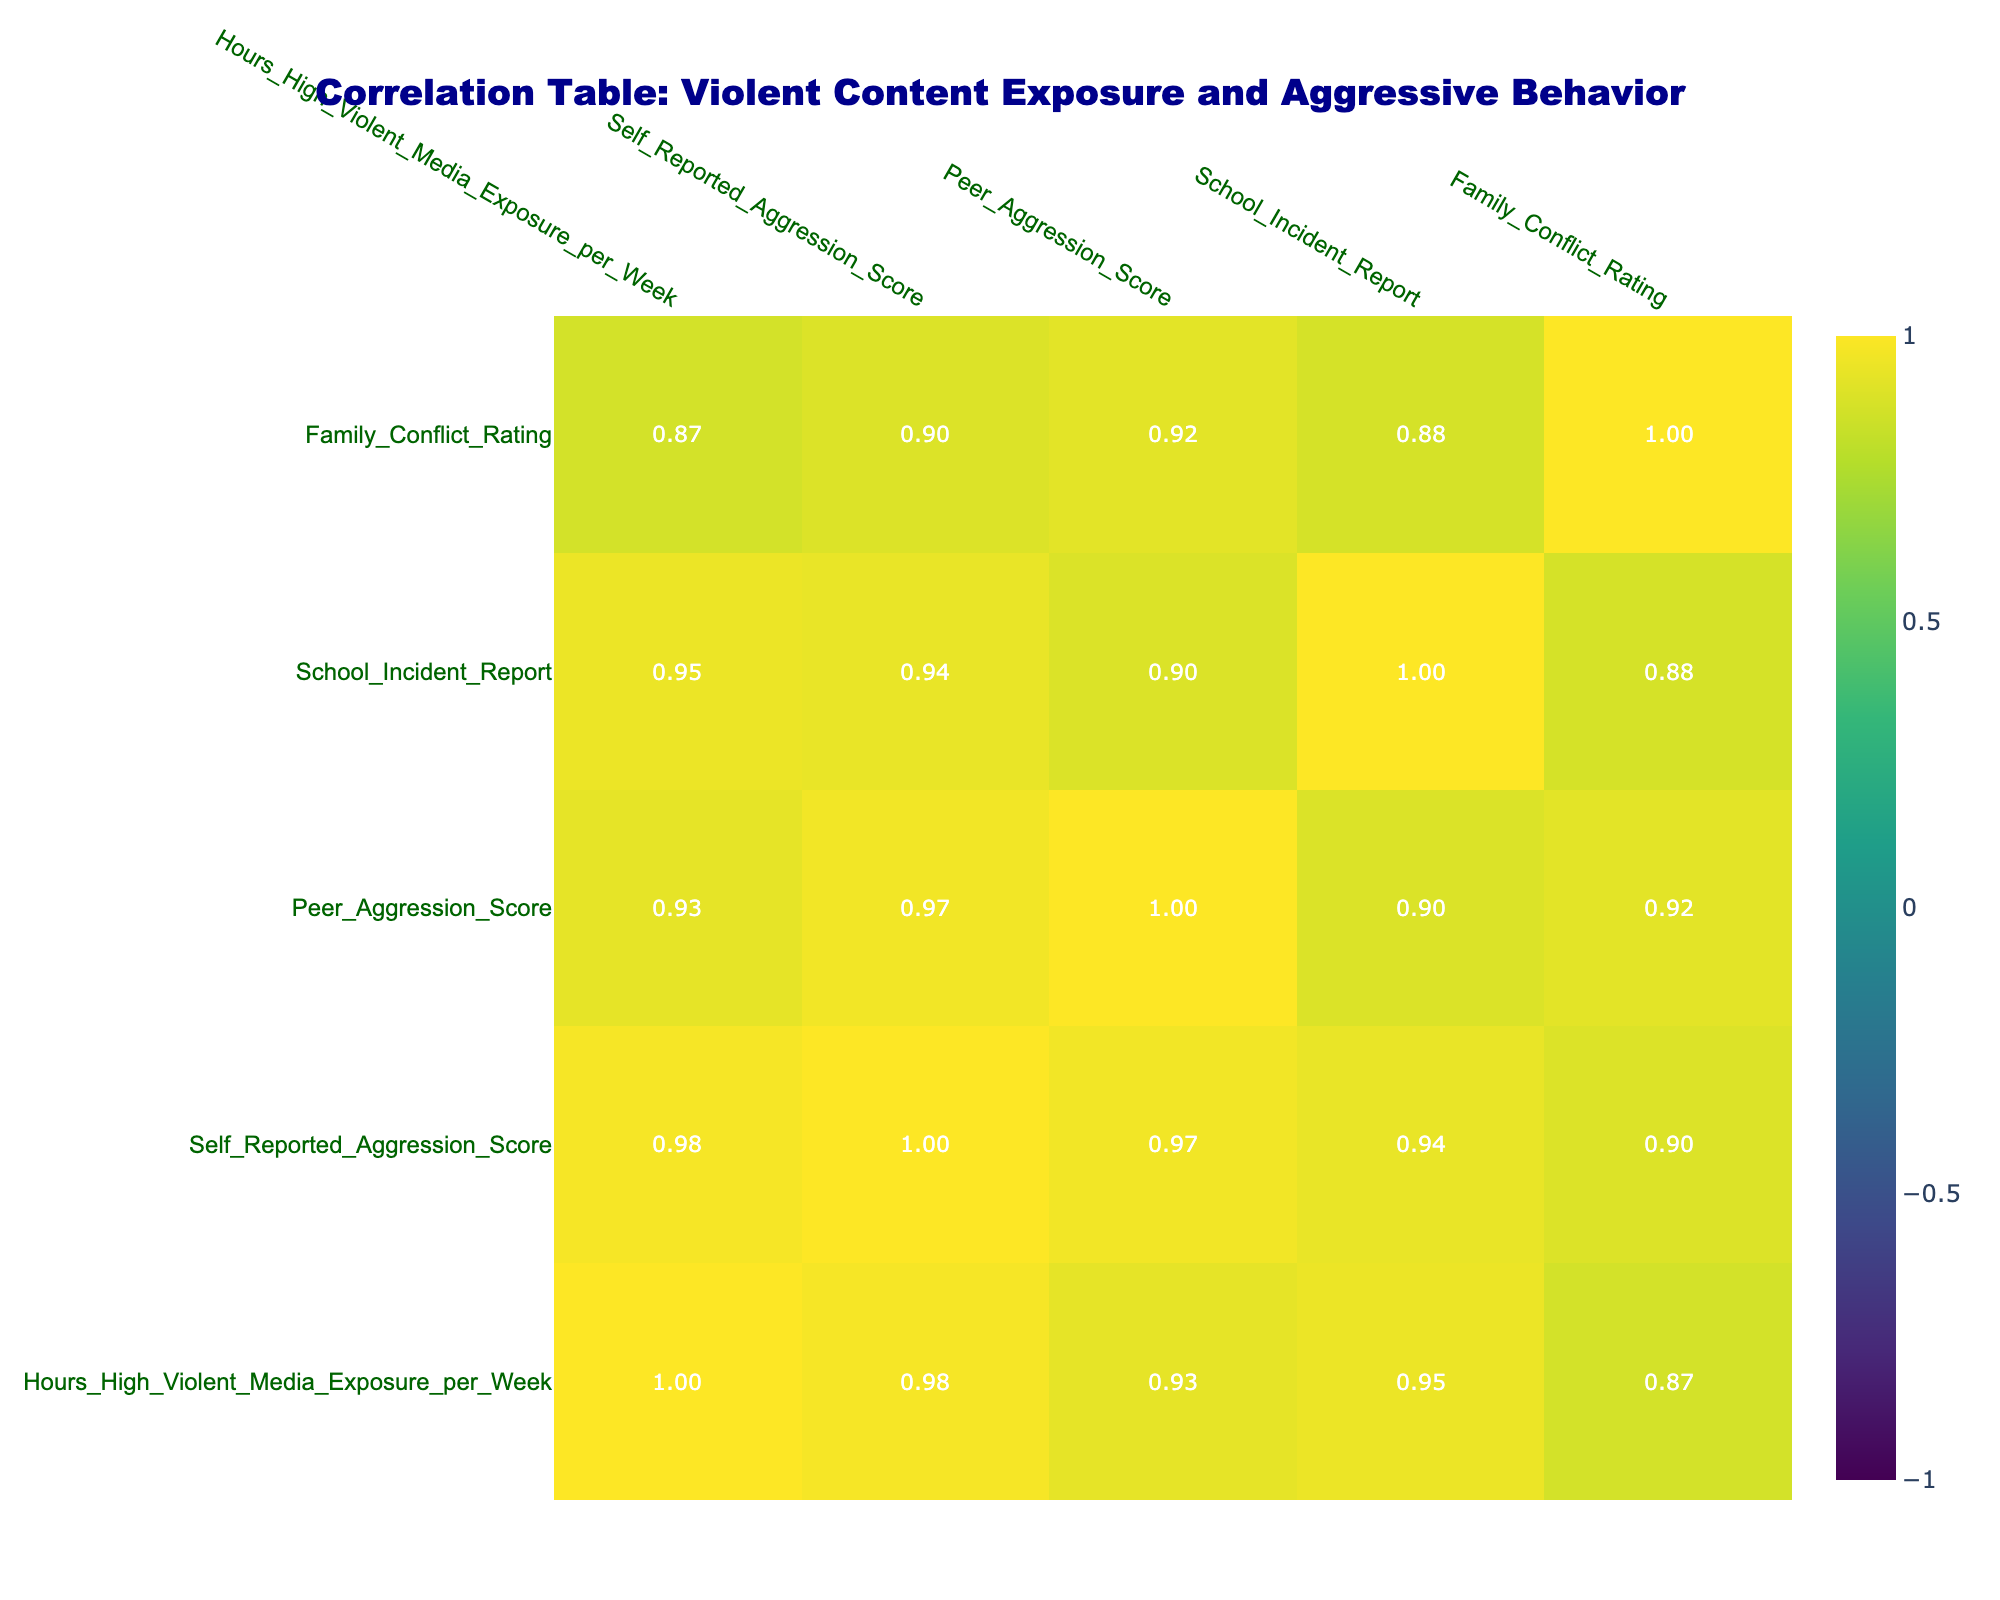What is the correlation between hours of high violent media exposure and self-reported aggression score? The correlation coefficient value between "Hours_High_Violent_Media_Exposure_per_Week" and "Self_Reported_Aggression_Score" is present in the table. By examining the appropriate cell, we find that it is 0.81.
Answer: 0.81 Is there a negative correlation between peer aggression score and hours of high violent media exposure? The correlation coefficient for "Peer_Aggression_Score" and "Hours_High_Violent_Media_Exposure_per_Week" can be found in the table. This value is 0.78, indicating a strong positive correlation rather than a negative one.
Answer: No What is the average self-reported aggression score for youths exposed to more than 10 hours of violent media per week? We first identify the youths exposed to more than 10 hours of violent media per week: Youth IDs 1 (7), 3 (8), 5 (9), and 9 (8). Next, we sum these scores: 7 + 8 + 9 + 8 = 32. There are 4 youths in this group, so the average is 32/4 = 8.
Answer: 8 Does the family conflict rating correlate strongly with self-reported aggression scores? We check the correlation coefficient between "Family_Conflict_Rating" and "Self_Reported_Aggression_Score". The table shows this correlation as 0.62, which indicates a moderate correlation but not a strong one, as values closer to 1 or -1 would suggest stronger correlations.
Answer: No What is the total number of school incident reports for youths with a family conflict rating above 3? We need to filter the table for entries with "Family_Conflict_Rating" greater than 3, which includes Youth IDs 1 (3), 5 (6), and 9 (4). The corresponding school incident reports are 3 (Youth 1), 6 (Youth 5), and 4 (Youth 9). The total is therefore 3 + 6 + 4 = 13.
Answer: 13 